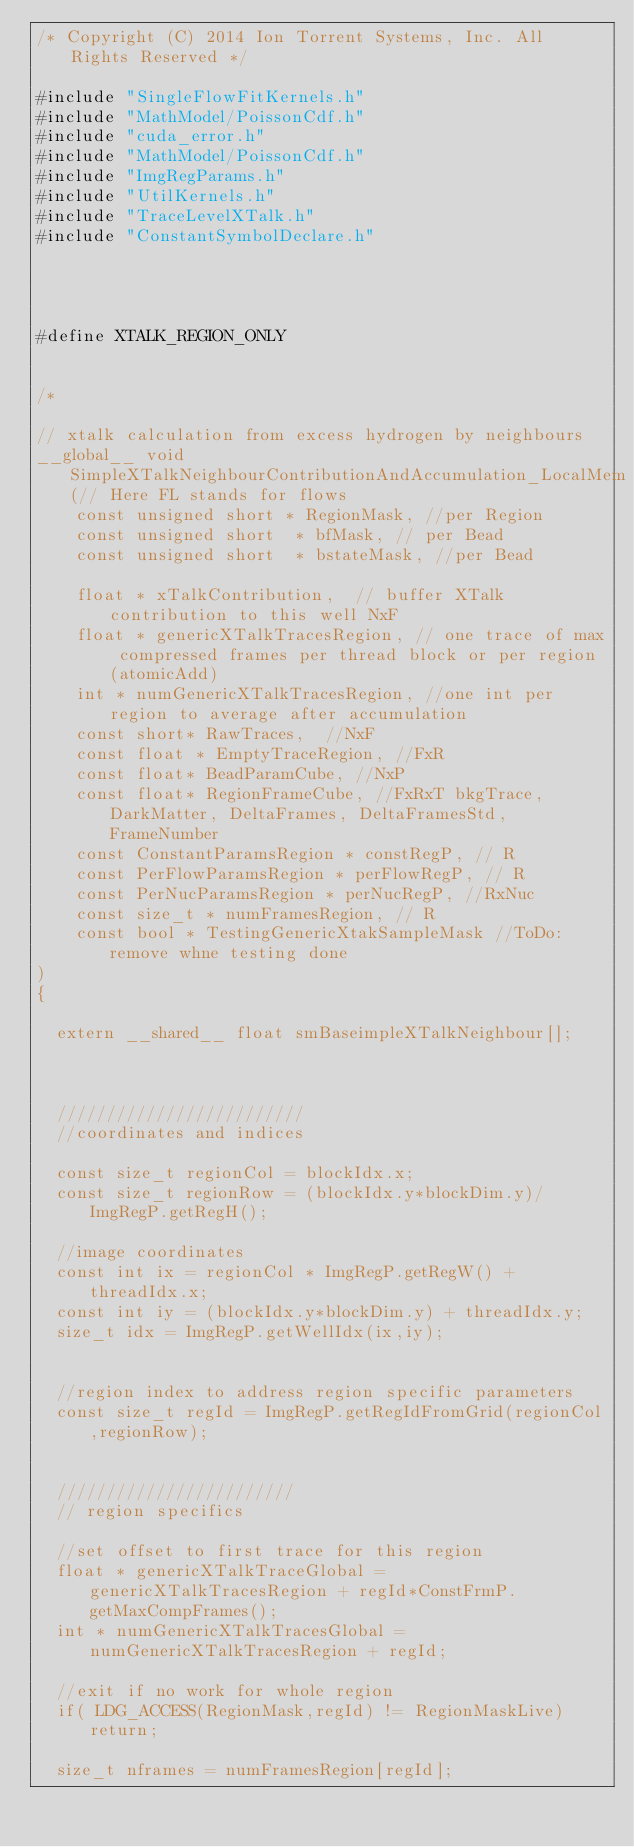<code> <loc_0><loc_0><loc_500><loc_500><_Cuda_>/* Copyright (C) 2014 Ion Torrent Systems, Inc. All Rights Reserved */

#include "SingleFlowFitKernels.h"
#include "MathModel/PoissonCdf.h"
#include "cuda_error.h"
#include "MathModel/PoissonCdf.h"
#include "ImgRegParams.h"
#include "UtilKernels.h"
#include "TraceLevelXTalk.h"
#include "ConstantSymbolDeclare.h"




#define XTALK_REGION_ONLY


/*

// xtalk calculation from excess hydrogen by neighbours
__global__ void SimpleXTalkNeighbourContributionAndAccumulation_LocalMem(// Here FL stands for flows
    const unsigned short * RegionMask, //per Region
    const unsigned short  * bfMask, // per Bead
    const unsigned short  * bstateMask, //per Bead

    float * xTalkContribution,  // buffer XTalk contribution to this well NxF
    float * genericXTalkTracesRegion, // one trace of max compressed frames per thread block or per region (atomicAdd)
    int * numGenericXTalkTracesRegion, //one int per region to average after accumulation
    const short* RawTraces,  //NxF
    const float * EmptyTraceRegion, //FxR
    const float* BeadParamCube, //NxP
    const float* RegionFrameCube, //FxRxT bkgTrace, DarkMatter, DeltaFrames, DeltaFramesStd, FrameNumber
    const ConstantParamsRegion * constRegP, // R
    const PerFlowParamsRegion * perFlowRegP, // R
    const PerNucParamsRegion * perNucRegP, //RxNuc
    const size_t * numFramesRegion, // R
    const bool * TestingGenericXtakSampleMask //ToDo: remove whne testing done
)
{

  extern __shared__ float smBaseimpleXTalkNeighbour[];



  /////////////////////////
  //coordinates and indices

  const size_t regionCol = blockIdx.x;
  const size_t regionRow = (blockIdx.y*blockDim.y)/ImgRegP.getRegH();

  //image coordinates
  const int ix = regionCol * ImgRegP.getRegW() + threadIdx.x;
  const int iy = (blockIdx.y*blockDim.y) + threadIdx.y;
  size_t idx = ImgRegP.getWellIdx(ix,iy);


  //region index to address region specific parameters
  const size_t regId = ImgRegP.getRegIdFromGrid(regionCol,regionRow);


  ////////////////////////
  // region specifics

  //set offset to first trace for this region
  float * genericXTalkTraceGlobal = genericXTalkTracesRegion + regId*ConstFrmP.getMaxCompFrames();
  int * numGenericXTalkTracesGlobal = numGenericXTalkTracesRegion + regId;

  //exit if no work for whole region
  if( LDG_ACCESS(RegionMask,regId) != RegionMaskLive) return;

  size_t nframes = numFramesRegion[regId];</code> 